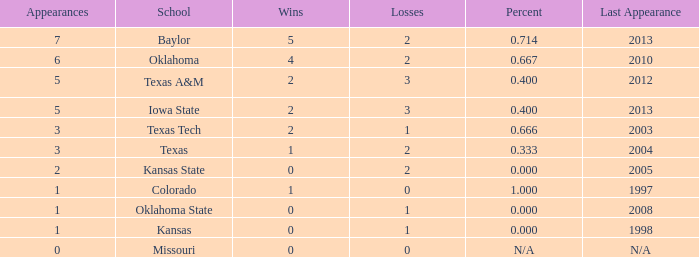How many wins did Baylor have?  1.0. 